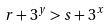Convert formula to latex. <formula><loc_0><loc_0><loc_500><loc_500>r + 3 ^ { y } > s + 3 ^ { x }</formula> 